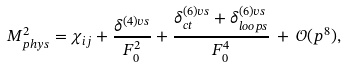<formula> <loc_0><loc_0><loc_500><loc_500>M _ { p h y s } ^ { 2 } = \chi _ { i j } + \frac { \delta ^ { ( 4 ) v s } } { F _ { 0 } ^ { 2 } } + \frac { \delta ^ { ( 6 ) v s } _ { c t } + \delta ^ { ( 6 ) v s } _ { l o o p s } } { F _ { 0 } ^ { 4 } } \, + \, \mathcal { O } ( p ^ { 8 } ) ,</formula> 